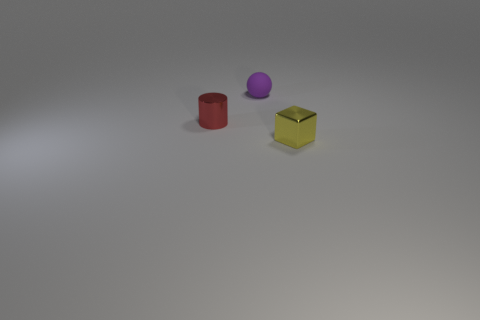Add 2 large metal cylinders. How many objects exist? 5 Subtract all blocks. How many objects are left? 2 Subtract all large red matte cylinders. Subtract all small matte spheres. How many objects are left? 2 Add 3 spheres. How many spheres are left? 4 Add 2 rubber balls. How many rubber balls exist? 3 Subtract 0 brown cubes. How many objects are left? 3 